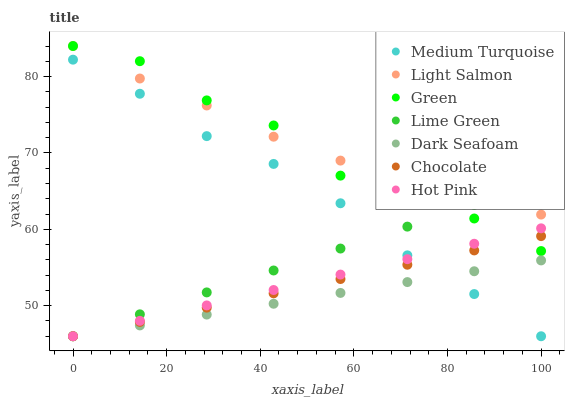Does Dark Seafoam have the minimum area under the curve?
Answer yes or no. Yes. Does Light Salmon have the maximum area under the curve?
Answer yes or no. Yes. Does Hot Pink have the minimum area under the curve?
Answer yes or no. No. Does Hot Pink have the maximum area under the curve?
Answer yes or no. No. Is Dark Seafoam the smoothest?
Answer yes or no. Yes. Is Green the roughest?
Answer yes or no. Yes. Is Hot Pink the smoothest?
Answer yes or no. No. Is Hot Pink the roughest?
Answer yes or no. No. Does Hot Pink have the lowest value?
Answer yes or no. Yes. Does Green have the lowest value?
Answer yes or no. No. Does Green have the highest value?
Answer yes or no. Yes. Does Hot Pink have the highest value?
Answer yes or no. No. Is Medium Turquoise less than Light Salmon?
Answer yes or no. Yes. Is Green greater than Dark Seafoam?
Answer yes or no. Yes. Does Medium Turquoise intersect Hot Pink?
Answer yes or no. Yes. Is Medium Turquoise less than Hot Pink?
Answer yes or no. No. Is Medium Turquoise greater than Hot Pink?
Answer yes or no. No. Does Medium Turquoise intersect Light Salmon?
Answer yes or no. No. 